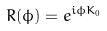Convert formula to latex. <formula><loc_0><loc_0><loc_500><loc_500>R ( \phi ) = e ^ { i \phi K _ { 0 } }</formula> 